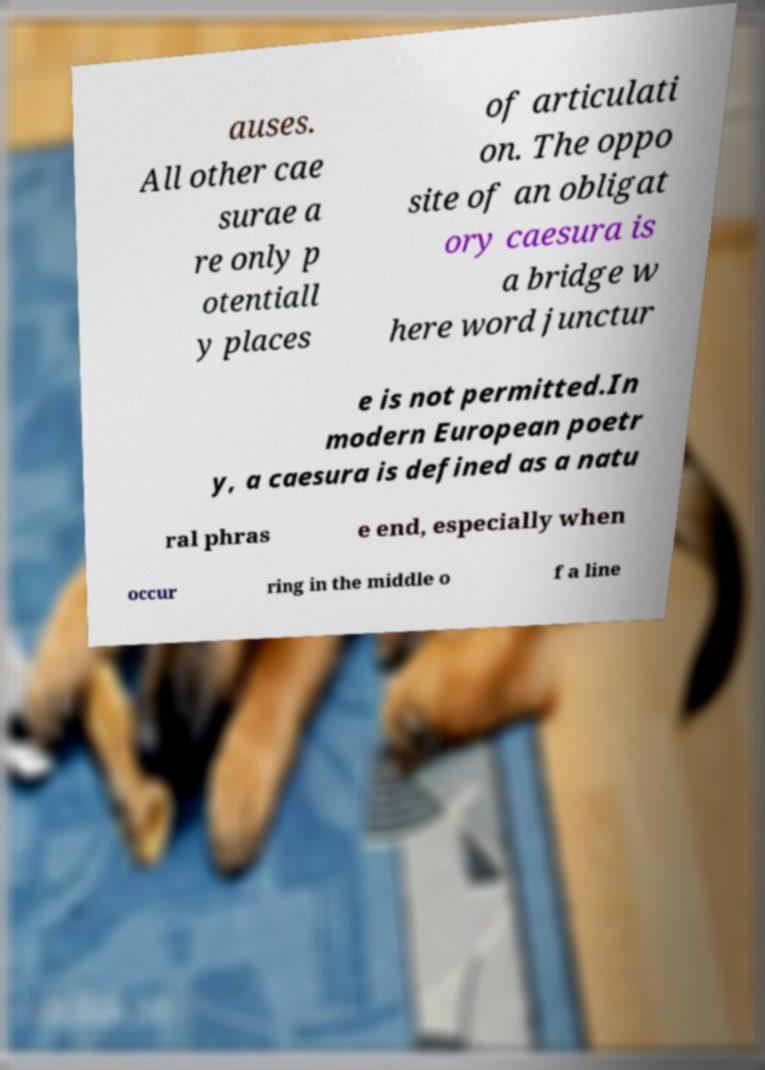For documentation purposes, I need the text within this image transcribed. Could you provide that? auses. All other cae surae a re only p otentiall y places of articulati on. The oppo site of an obligat ory caesura is a bridge w here word junctur e is not permitted.In modern European poetr y, a caesura is defined as a natu ral phras e end, especially when occur ring in the middle o f a line 